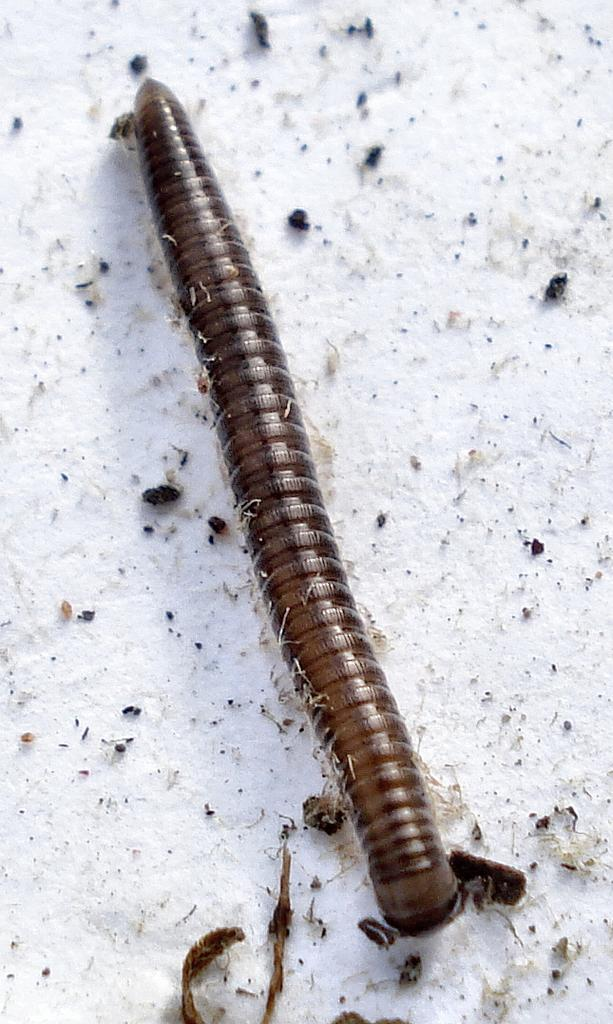What type of creature is on the ground in the image? There is a caterpillar on the ground in the image. What is covering the ground in the image? There is snow on the ground in the image. What position does the porter hold in the image? There is no porter present in the image. What type of wind can be seen blowing in the image? There is no wind visible in the image, and therefore no specific type of wind can be identified. 